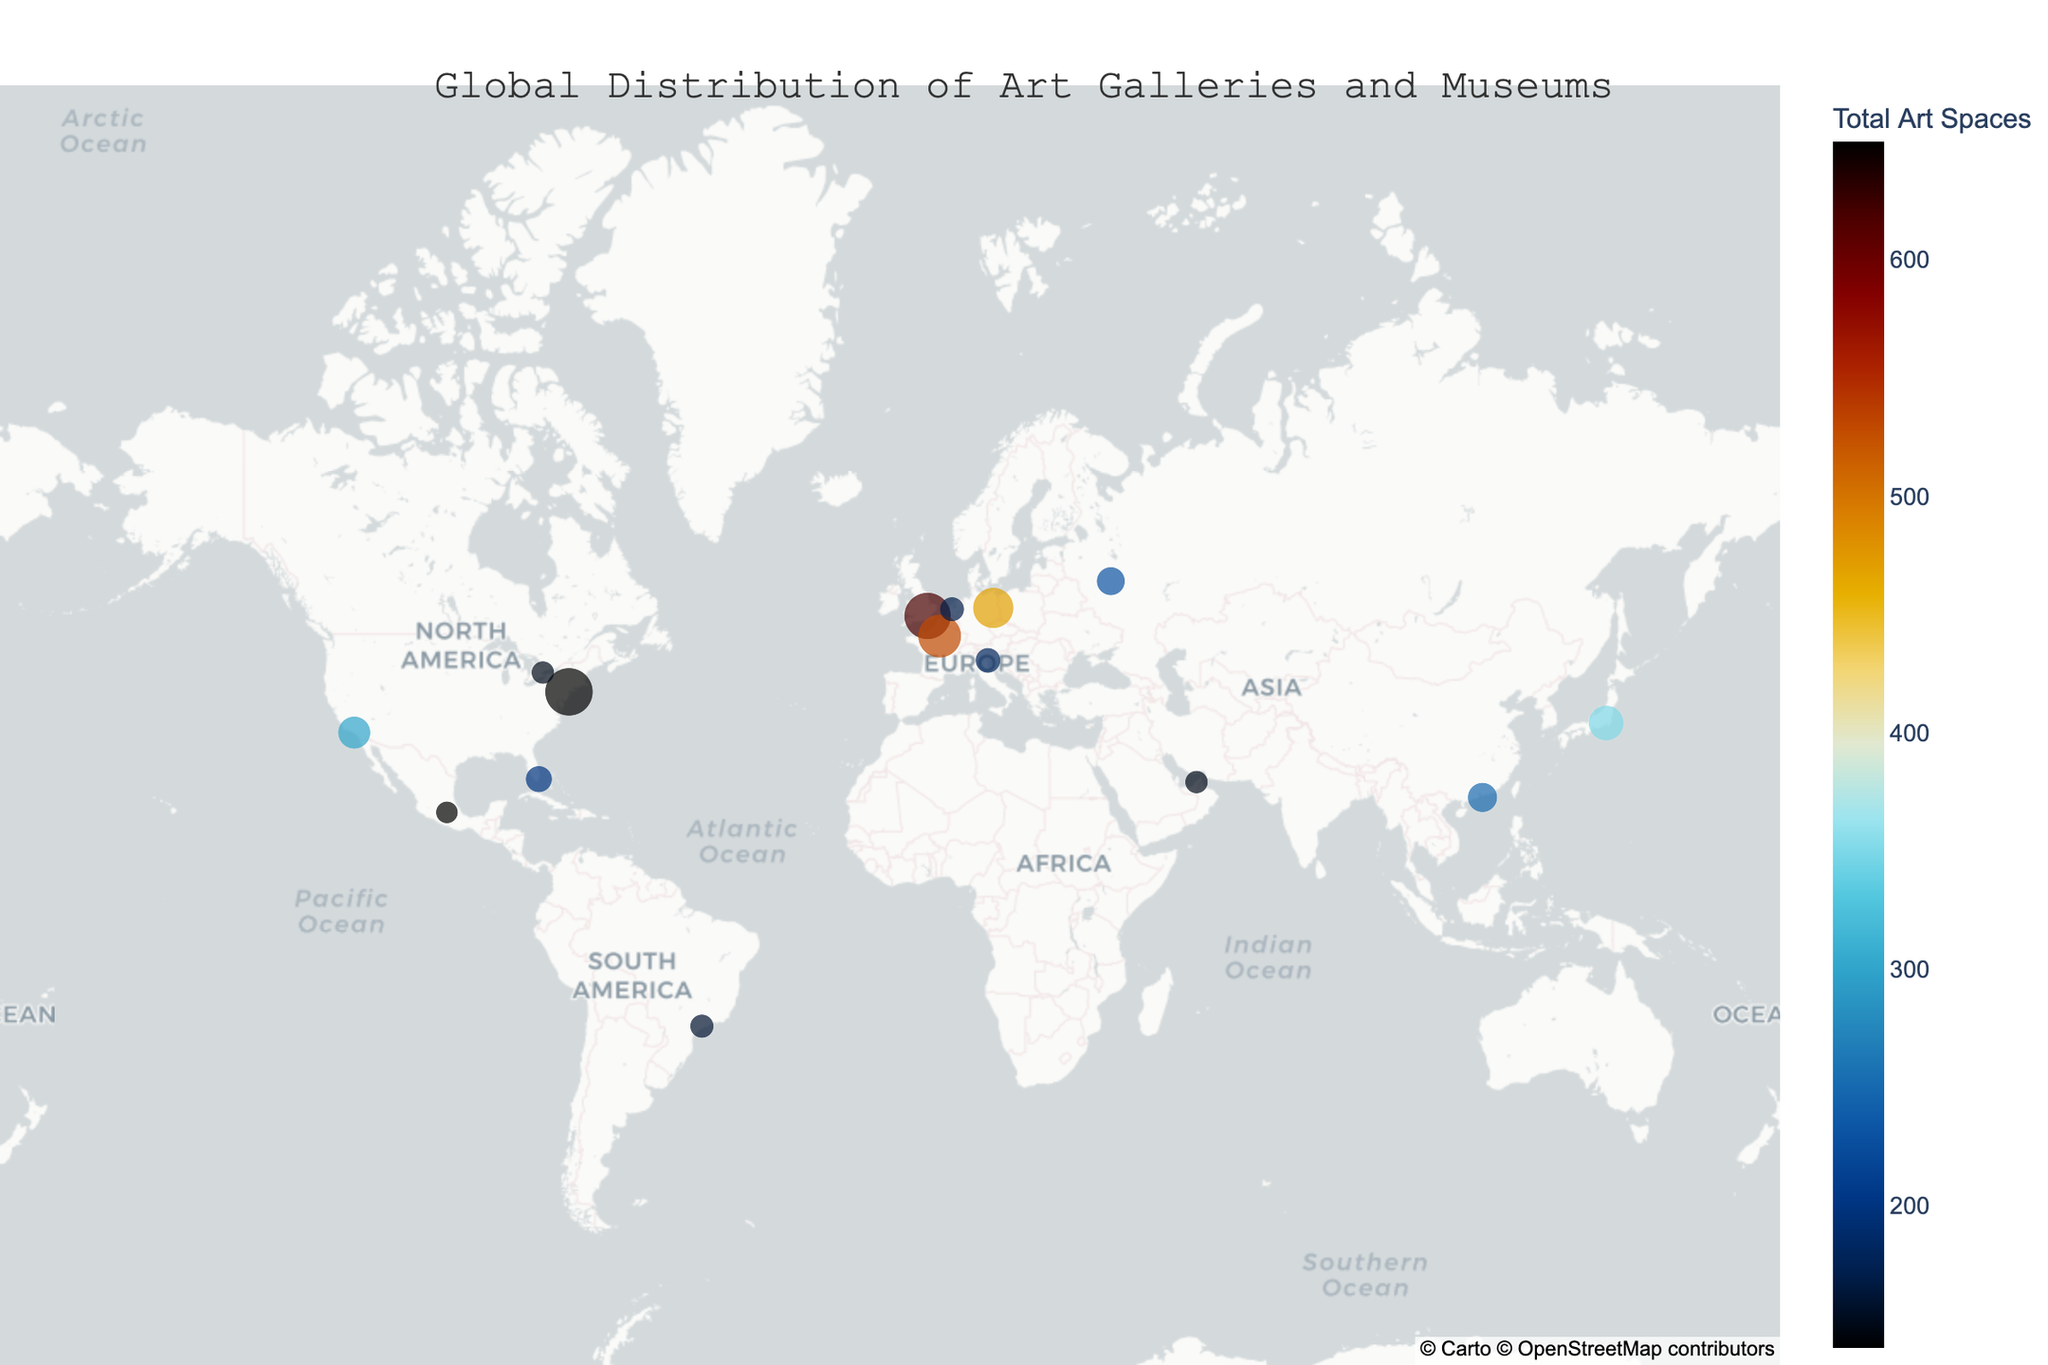Which city has the highest total number of art spaces? The city with the highest total number of art spaces will have the largest dot size on the map.
Answer: New York City What's the main title of the figure? The title is located at the top of the figure and summarizes the plot's main content.
Answer: Global Distribution of Art Galleries and Museums Which two cities have the same number of museums? Look at the total museums indicated in the hover data for each city. Identify pairs of cities with the same value.
Answer: London and Berlin What is the average number of museums in the cities listed? Sum the total number of museums for all cities, then divide by the number of cities. There are 15 cities. Sum = 1,460, Average = 1,460 / 15.
Answer: 97.33 How many art galleries are there in total in all the cities combined? Sum the number of art galleries for each city: 500+450+400+300+250+200+150+180+100+120+140+110+90+80+100
Answer: 3070 Which city has the lowest number of art spaces, and how many? Identify the city with the smallest dot size and check its total art spaces via hover data on the map.
Answer: Dubai with 150 How does the total number of art spaces in Paris compare to Berlin? Look at the total art spaces for Paris and Berlin via hover data. Paris has 530, and Berlin has 470.
Answer: Paris has more Which continent has the highest number of cities with major art spaces? Observe the geographic positions of the cities on the map and identify the continent with the most markers. Ensure to consider each city's location across different continents.
Answer: North America Out of Tokyo, Hong Kong, and São Paulo, which city has the highest number of art galleries? Refer to the hover data for each of these cities and compare the number of art galleries listed: Tokyo (250), Hong Kong (180), São Paulo (90).
Answer: Tokyo If two cities had an equal number of total art spaces, but New York City had 20 more art galleries, how many museums would the other city have? New York has 150 museums and a total of 650 art spaces (subtract art galleries: 650 - 500 = 150). With 20 more galleries, the other city would need the same visualized 650 total spaces. So (650 - (500 + 20) = 130). Thus, it needs 130 museums.
Answer: 130 